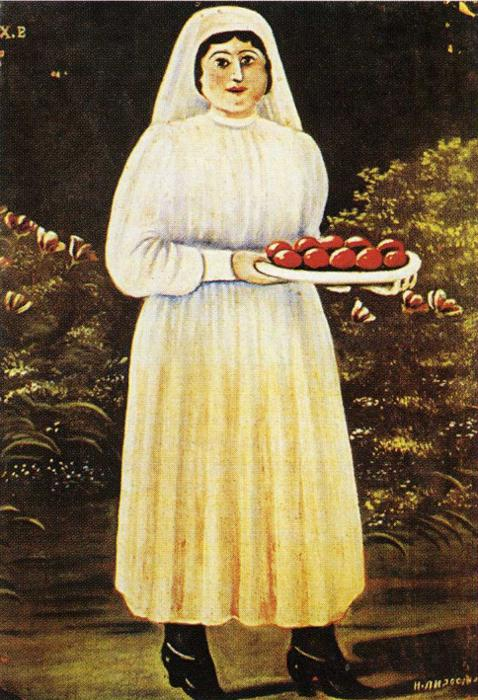Can you tell me more about the artistic techniques used in this painting? This painting exemplifies folk art techniques, characterized by its straightforward and unsophisticated aesthetic. Folk artists often use bold colors that stand out starkly against their backgrounds, as seen here with the vibrant reds and greens against the dark backdrop. The proportions and details of the figure are intentionally simple, focusing more on symbolic representation than realism. The brush strokes are deliberate and clear, contributing to the work’s overall clarity and simplicity. 